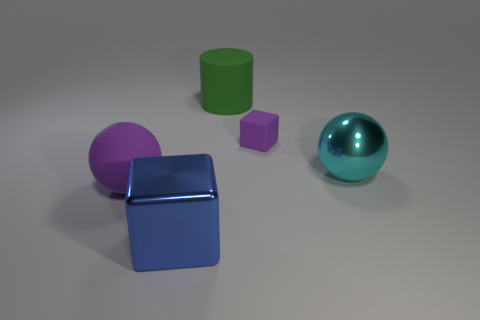Add 5 small blue matte objects. How many objects exist? 10 Subtract all cylinders. How many objects are left? 4 Subtract all large blue shiny objects. Subtract all large brown objects. How many objects are left? 4 Add 2 metallic cubes. How many metallic cubes are left? 3 Add 2 big yellow blocks. How many big yellow blocks exist? 2 Subtract 0 yellow cylinders. How many objects are left? 5 